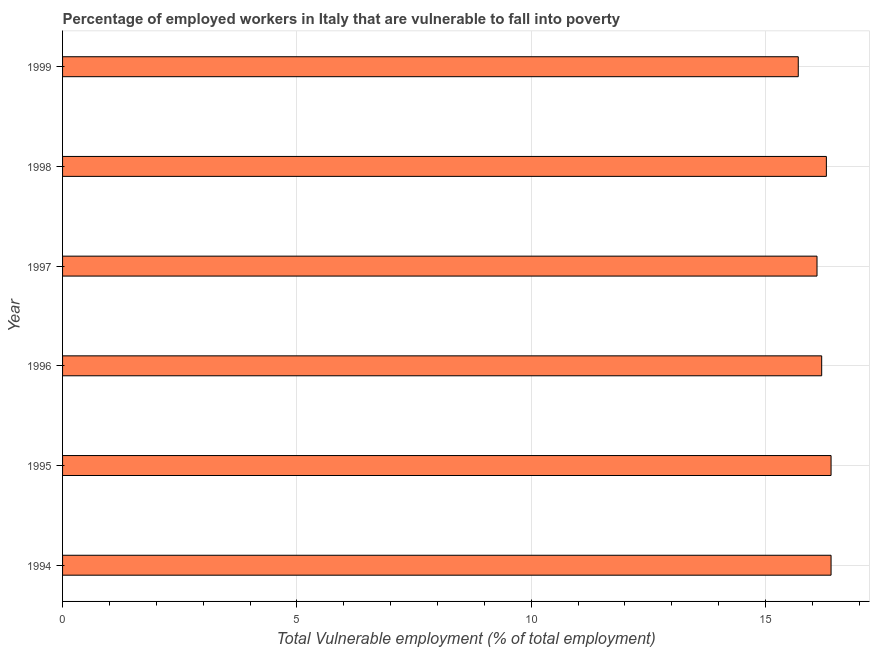Does the graph contain grids?
Your response must be concise. Yes. What is the title of the graph?
Provide a short and direct response. Percentage of employed workers in Italy that are vulnerable to fall into poverty. What is the label or title of the X-axis?
Your answer should be compact. Total Vulnerable employment (% of total employment). What is the label or title of the Y-axis?
Your answer should be compact. Year. What is the total vulnerable employment in 1996?
Your answer should be compact. 16.2. Across all years, what is the maximum total vulnerable employment?
Offer a very short reply. 16.4. Across all years, what is the minimum total vulnerable employment?
Provide a short and direct response. 15.7. In which year was the total vulnerable employment minimum?
Your answer should be compact. 1999. What is the sum of the total vulnerable employment?
Give a very brief answer. 97.1. What is the average total vulnerable employment per year?
Your response must be concise. 16.18. What is the median total vulnerable employment?
Your answer should be compact. 16.25. What is the ratio of the total vulnerable employment in 1996 to that in 1999?
Offer a very short reply. 1.03. What is the difference between the highest and the second highest total vulnerable employment?
Give a very brief answer. 0. Is the sum of the total vulnerable employment in 1996 and 1999 greater than the maximum total vulnerable employment across all years?
Provide a short and direct response. Yes. What is the difference between the highest and the lowest total vulnerable employment?
Offer a terse response. 0.7. In how many years, is the total vulnerable employment greater than the average total vulnerable employment taken over all years?
Keep it short and to the point. 4. Are the values on the major ticks of X-axis written in scientific E-notation?
Your response must be concise. No. What is the Total Vulnerable employment (% of total employment) of 1994?
Make the answer very short. 16.4. What is the Total Vulnerable employment (% of total employment) in 1995?
Your response must be concise. 16.4. What is the Total Vulnerable employment (% of total employment) in 1996?
Your answer should be compact. 16.2. What is the Total Vulnerable employment (% of total employment) of 1997?
Give a very brief answer. 16.1. What is the Total Vulnerable employment (% of total employment) of 1998?
Provide a succinct answer. 16.3. What is the Total Vulnerable employment (% of total employment) of 1999?
Your answer should be compact. 15.7. What is the difference between the Total Vulnerable employment (% of total employment) in 1994 and 1995?
Your response must be concise. 0. What is the difference between the Total Vulnerable employment (% of total employment) in 1994 and 1996?
Your answer should be compact. 0.2. What is the difference between the Total Vulnerable employment (% of total employment) in 1995 and 1996?
Keep it short and to the point. 0.2. What is the difference between the Total Vulnerable employment (% of total employment) in 1995 and 1997?
Provide a succinct answer. 0.3. What is the difference between the Total Vulnerable employment (% of total employment) in 1996 and 1997?
Provide a succinct answer. 0.1. What is the difference between the Total Vulnerable employment (% of total employment) in 1996 and 1999?
Provide a succinct answer. 0.5. What is the difference between the Total Vulnerable employment (% of total employment) in 1998 and 1999?
Make the answer very short. 0.6. What is the ratio of the Total Vulnerable employment (% of total employment) in 1994 to that in 1996?
Provide a short and direct response. 1.01. What is the ratio of the Total Vulnerable employment (% of total employment) in 1994 to that in 1999?
Offer a very short reply. 1.04. What is the ratio of the Total Vulnerable employment (% of total employment) in 1995 to that in 1997?
Give a very brief answer. 1.02. What is the ratio of the Total Vulnerable employment (% of total employment) in 1995 to that in 1998?
Make the answer very short. 1.01. What is the ratio of the Total Vulnerable employment (% of total employment) in 1995 to that in 1999?
Ensure brevity in your answer.  1.04. What is the ratio of the Total Vulnerable employment (% of total employment) in 1996 to that in 1997?
Your answer should be very brief. 1.01. What is the ratio of the Total Vulnerable employment (% of total employment) in 1996 to that in 1998?
Offer a terse response. 0.99. What is the ratio of the Total Vulnerable employment (% of total employment) in 1996 to that in 1999?
Give a very brief answer. 1.03. What is the ratio of the Total Vulnerable employment (% of total employment) in 1997 to that in 1998?
Provide a short and direct response. 0.99. What is the ratio of the Total Vulnerable employment (% of total employment) in 1998 to that in 1999?
Keep it short and to the point. 1.04. 